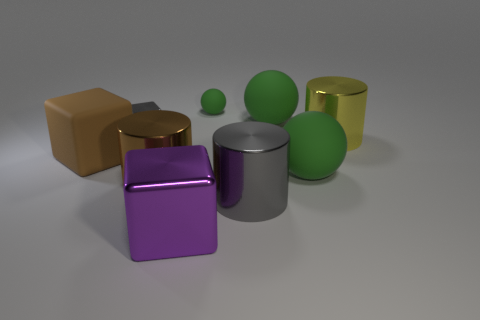What is the color of the small thing that is the same material as the yellow cylinder?
Keep it short and to the point. Gray. Are there fewer tiny yellow rubber cylinders than purple shiny objects?
Offer a terse response. Yes. What is the big object that is both in front of the brown metal thing and to the left of the small matte sphere made of?
Provide a succinct answer. Metal. There is a big matte object that is to the left of the brown shiny cylinder; are there any purple metal cubes that are behind it?
Your response must be concise. No. How many other matte blocks are the same color as the matte block?
Your response must be concise. 0. There is a cylinder that is the same color as the small metal cube; what is it made of?
Offer a very short reply. Metal. Do the big yellow object and the big brown block have the same material?
Give a very brief answer. No. There is a big gray metallic cylinder; are there any tiny green matte balls right of it?
Provide a short and direct response. No. There is a yellow cylinder in front of the gray metallic thing left of the purple metallic cube; what is its material?
Provide a succinct answer. Metal. There is a yellow metallic object that is the same shape as the brown metal object; what is its size?
Make the answer very short. Large. 